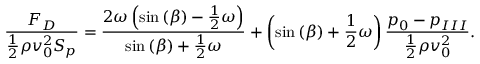<formula> <loc_0><loc_0><loc_500><loc_500>\frac { F _ { D } } { \frac { 1 } { 2 } \rho v _ { 0 } ^ { 2 } S _ { p } } = \frac { 2 \omega \left ( \sin { ( \beta ) } - \frac { 1 } { 2 } \omega \right ) } { \sin { ( \beta ) } + \frac { 1 } { 2 } \omega } + \left ( \sin { ( \beta ) } + \frac { 1 } { 2 } \omega \right ) \frac { { p _ { 0 } } - { p _ { I I I } } } { \frac { 1 } { 2 } \rho v _ { 0 } ^ { 2 } } .</formula> 